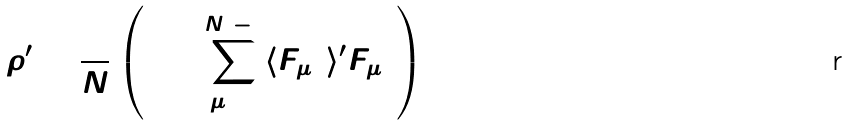Convert formula to latex. <formula><loc_0><loc_0><loc_500><loc_500>\rho ^ { \prime } = \frac { 1 } { N } \left ( 1 + \sum _ { \mu = 1 } ^ { N ^ { 2 } - 1 } \langle F _ { \mu 0 } \rangle ^ { \prime } F _ { \mu 0 } \right )</formula> 